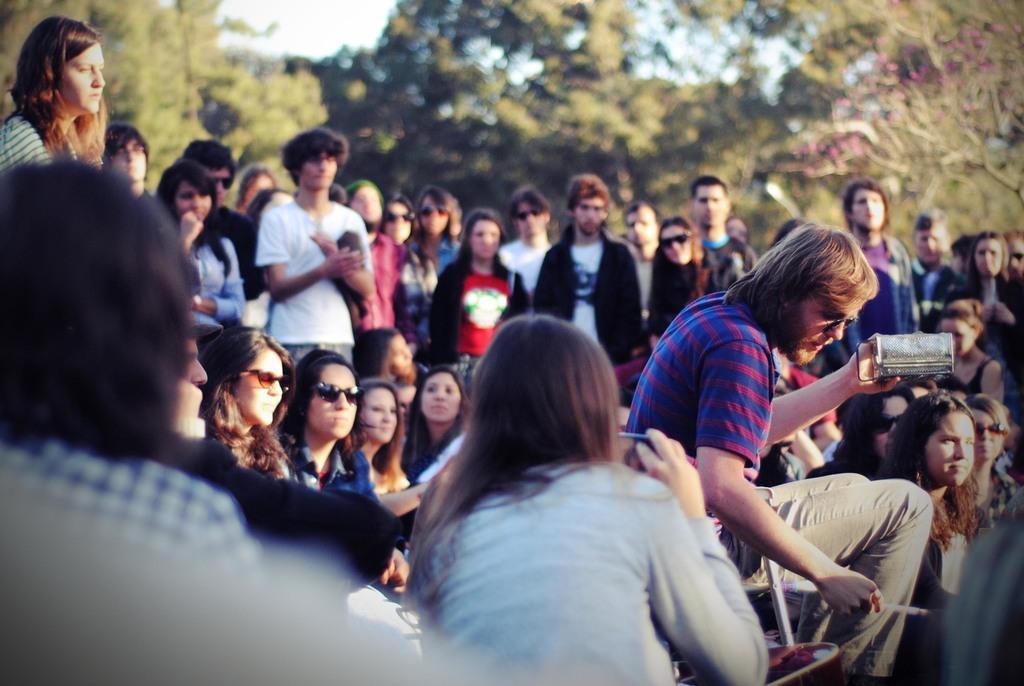Describe this image in one or two sentences. At the bottom of the picture, we see people sitting. Behind them, there are many people standing. The man in blue T-shirt is holding something in his hand. There are trees in the background. At the top of the picture, we see the sky. This picture is clicked outside the city. 